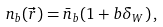<formula> <loc_0><loc_0><loc_500><loc_500>n _ { b } ( \vec { r } ) = \bar { n } _ { b } ( 1 + b \delta _ { W } ) \, ,</formula> 